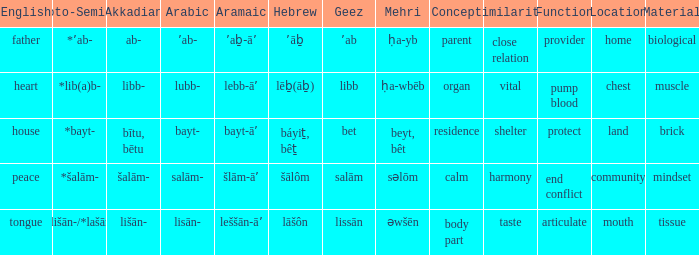If the proto-semitic is *bayt-, what are the geez? Bet. 